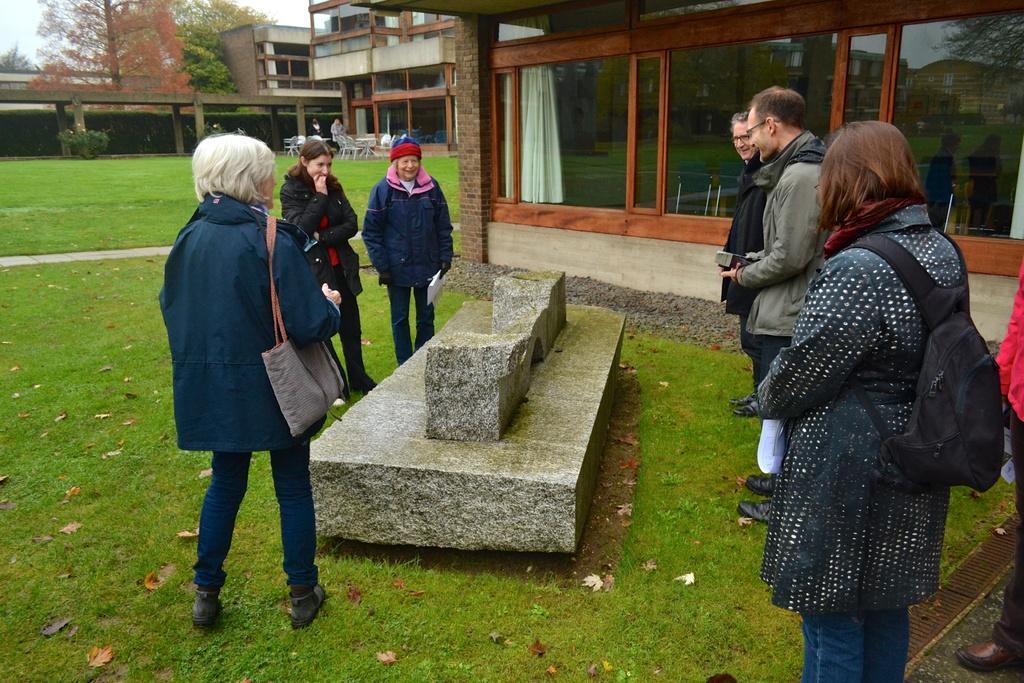Describe this image in one or two sentences. In this image we can see a few people around a stone, two of them are holding papers, there are houses, windows, curtain, there are plants, trees, also we can see the sky, and leaves on the ground. 